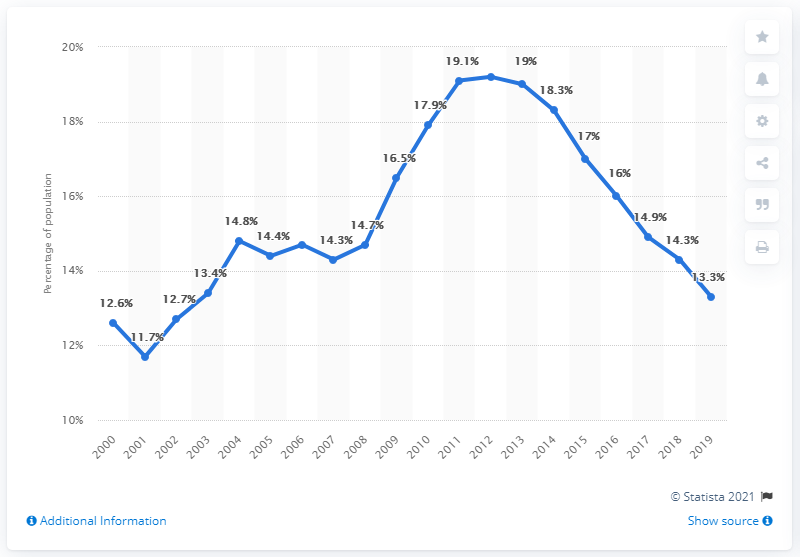Mention a couple of crucial points in this snapshot. The poverty rate in the state of Georgia was 13.3% in 2019. The poverty rate in Georgia ranged from 7.4% in the lowest poverty rate to 18.5% in the highest poverty rate. 